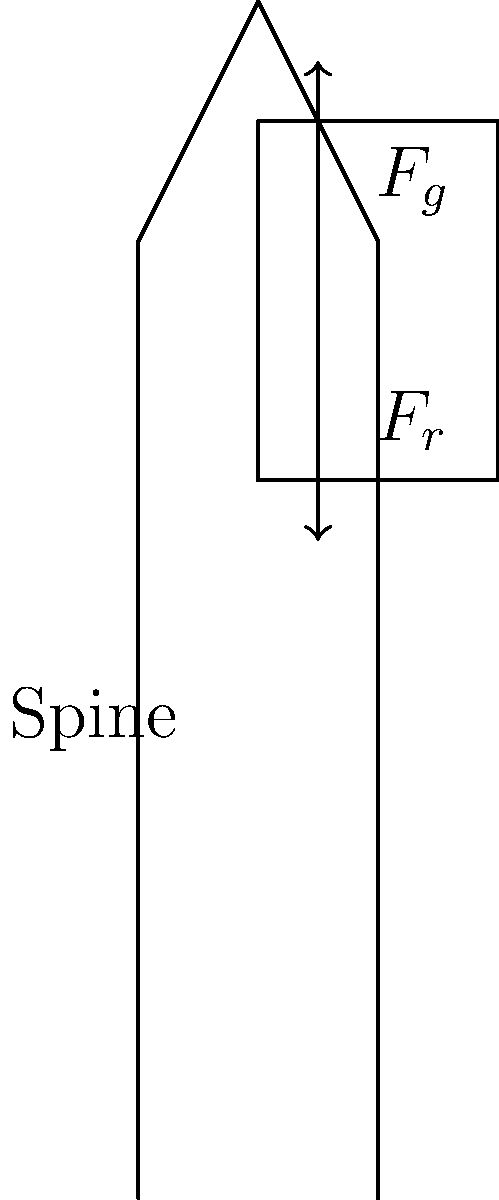During your travels, you often carried a heavy backpack. Consider a situation where you're standing upright with a 20 kg backpack. If the center of mass of the backpack is 30 cm from your spine, what is the approximate moment (torque) exerted on your lower back? Assume gravity is 9.8 m/s². To solve this problem, we'll follow these steps:

1. Identify the relevant information:
   - Mass of the backpack (m) = 20 kg
   - Distance from spine to center of mass of backpack (d) = 30 cm = 0.3 m
   - Acceleration due to gravity (g) = 9.8 m/s²

2. Calculate the force exerted by the backpack:
   $F = m \times g$
   $F = 20 \text{ kg} \times 9.8 \text{ m/s²} = 196 \text{ N}$

3. Calculate the moment (torque) using the formula:
   $\tau = F \times d$
   Where:
   $\tau$ is the moment (torque)
   $F$ is the force
   $d$ is the perpendicular distance from the axis of rotation (spine) to the line of action of the force

4. Substitute the values:
   $\tau = 196 \text{ N} \times 0.3 \text{ m} = 58.8 \text{ N·m}$

5. Round to a reasonable number of significant figures:
   $\tau \approx 59 \text{ N·m}$

This moment represents the rotational force experienced by your lower back due to the weight of the backpack, which can contribute to back strain during extended periods of travel.
Answer: 59 N·m 